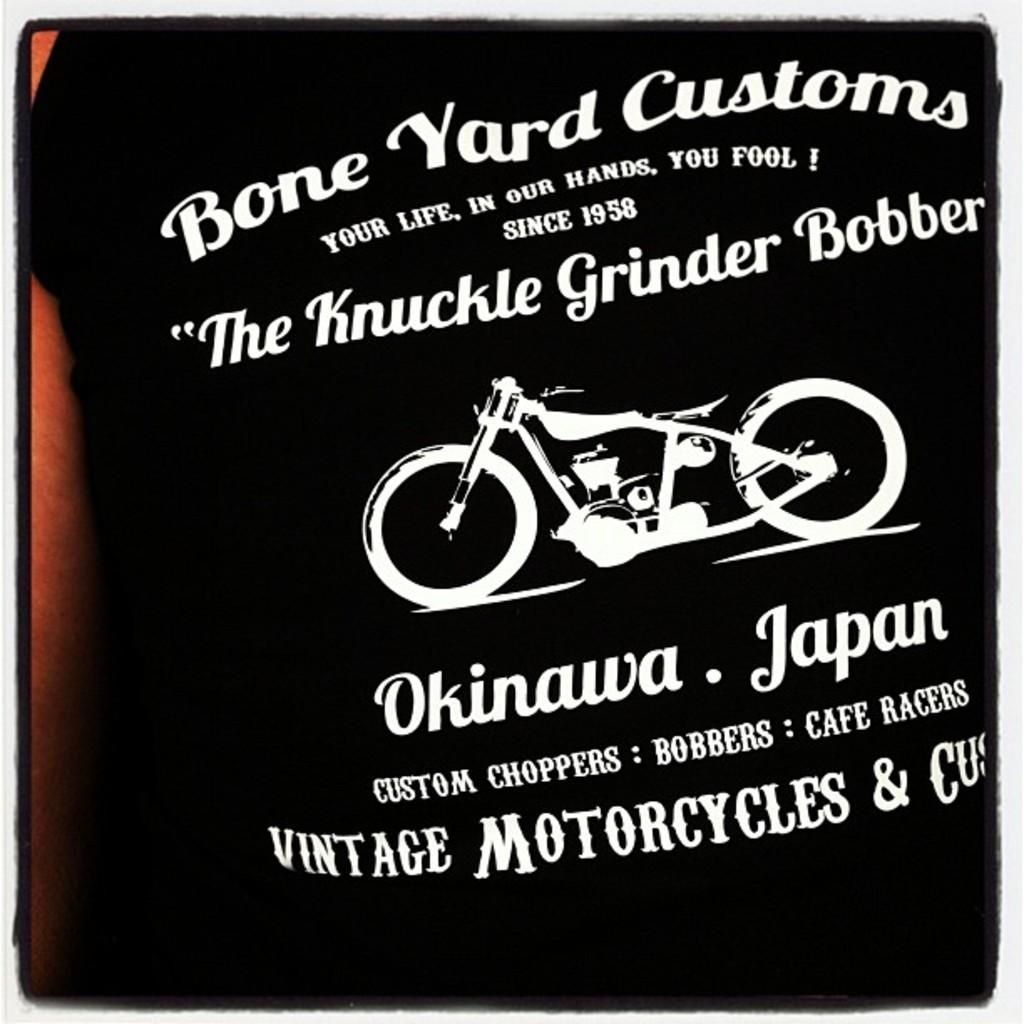What is depicted in the paintings in the image? The paintings in the image depict a bike. What is on the black T-shirt in the image? There are texts on the black T-shirt in the image. What type of riddle is written on the bike in the image? There is no riddle written on the bike in the image; it is a painting of a bike. What shape is the cub in the image? There is no cub present in the image. 